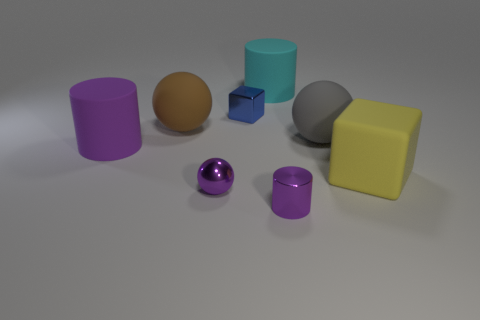Add 2 tiny purple balls. How many objects exist? 10 Subtract all spheres. How many objects are left? 5 Add 7 tiny objects. How many tiny objects are left? 10 Add 3 blue cubes. How many blue cubes exist? 4 Subtract 1 blue blocks. How many objects are left? 7 Subtract all small yellow shiny blocks. Subtract all large rubber blocks. How many objects are left? 7 